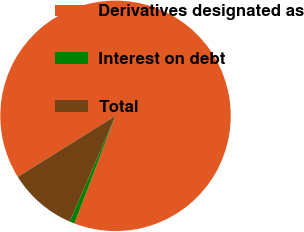Convert chart. <chart><loc_0><loc_0><loc_500><loc_500><pie_chart><fcel>Derivatives designated as<fcel>Interest on debt<fcel>Total<nl><fcel>89.68%<fcel>0.71%<fcel>9.61%<nl></chart> 